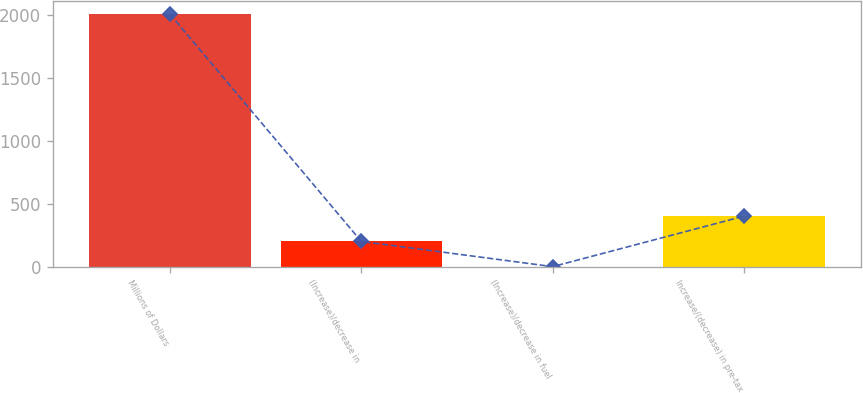<chart> <loc_0><loc_0><loc_500><loc_500><bar_chart><fcel>Millions of Dollars<fcel>(Increase)/decrease in<fcel>(Increase)/decrease in fuel<fcel>Increase/(decrease) in pre-tax<nl><fcel>2007<fcel>201.6<fcel>1<fcel>402.2<nl></chart> 